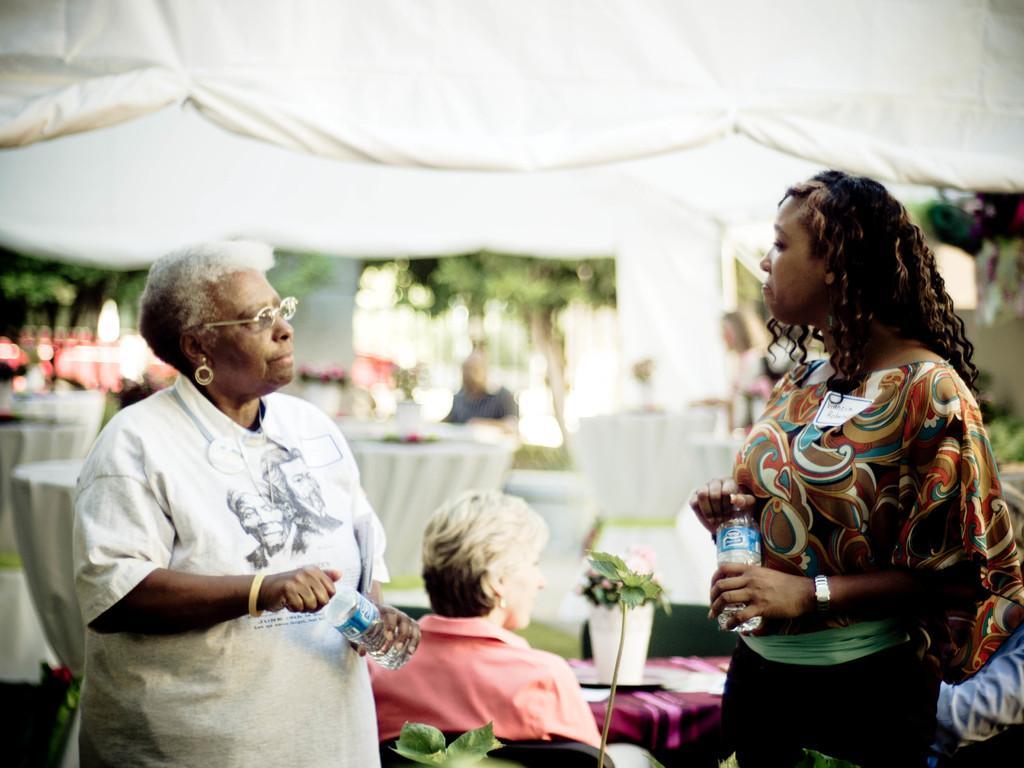Describe this image in one or two sentences. In this picture I can see two women are standing and holding bottles in their hands. In the background I can see people sitting in front of a tables. On the tables I can see some objects. 